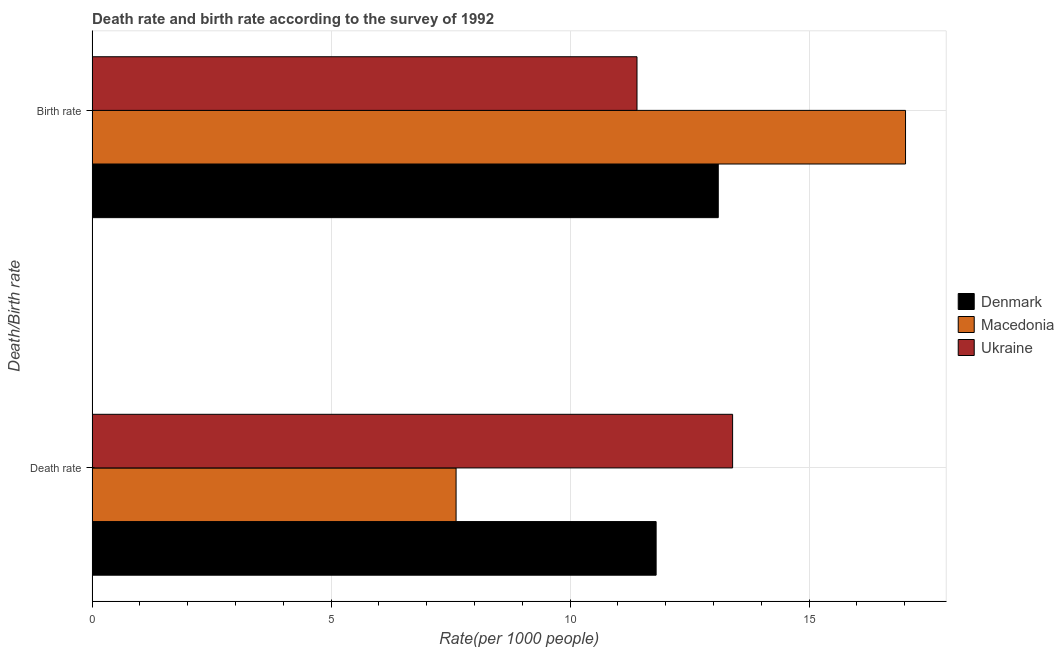How many bars are there on the 1st tick from the bottom?
Make the answer very short. 3. What is the label of the 1st group of bars from the top?
Keep it short and to the point. Birth rate. Across all countries, what is the maximum death rate?
Your response must be concise. 13.4. Across all countries, what is the minimum death rate?
Keep it short and to the point. 7.62. In which country was the birth rate maximum?
Your answer should be very brief. Macedonia. In which country was the death rate minimum?
Offer a terse response. Macedonia. What is the total birth rate in the graph?
Provide a short and direct response. 41.52. What is the difference between the death rate in Ukraine and that in Denmark?
Provide a short and direct response. 1.6. What is the difference between the death rate in Macedonia and the birth rate in Ukraine?
Your response must be concise. -3.79. What is the average birth rate per country?
Ensure brevity in your answer.  13.84. What is the difference between the death rate and birth rate in Denmark?
Your answer should be very brief. -1.3. What is the ratio of the death rate in Ukraine to that in Denmark?
Your response must be concise. 1.14. What does the 3rd bar from the bottom in Death rate represents?
Offer a very short reply. Ukraine. How many countries are there in the graph?
Your response must be concise. 3. Does the graph contain any zero values?
Your response must be concise. No. Where does the legend appear in the graph?
Your response must be concise. Center right. What is the title of the graph?
Offer a terse response. Death rate and birth rate according to the survey of 1992. Does "Bangladesh" appear as one of the legend labels in the graph?
Offer a very short reply. No. What is the label or title of the X-axis?
Provide a short and direct response. Rate(per 1000 people). What is the label or title of the Y-axis?
Make the answer very short. Death/Birth rate. What is the Rate(per 1000 people) in Denmark in Death rate?
Your answer should be compact. 11.8. What is the Rate(per 1000 people) of Macedonia in Death rate?
Your answer should be compact. 7.62. What is the Rate(per 1000 people) of Ukraine in Death rate?
Offer a terse response. 13.4. What is the Rate(per 1000 people) in Denmark in Birth rate?
Make the answer very short. 13.1. What is the Rate(per 1000 people) in Macedonia in Birth rate?
Your response must be concise. 17.02. Across all Death/Birth rate, what is the maximum Rate(per 1000 people) in Macedonia?
Give a very brief answer. 17.02. Across all Death/Birth rate, what is the minimum Rate(per 1000 people) in Denmark?
Keep it short and to the point. 11.8. Across all Death/Birth rate, what is the minimum Rate(per 1000 people) in Macedonia?
Offer a very short reply. 7.62. What is the total Rate(per 1000 people) of Denmark in the graph?
Give a very brief answer. 24.9. What is the total Rate(per 1000 people) in Macedonia in the graph?
Your answer should be compact. 24.63. What is the total Rate(per 1000 people) of Ukraine in the graph?
Offer a terse response. 24.8. What is the difference between the Rate(per 1000 people) in Denmark in Death rate and that in Birth rate?
Ensure brevity in your answer.  -1.3. What is the difference between the Rate(per 1000 people) of Macedonia in Death rate and that in Birth rate?
Your answer should be compact. -9.4. What is the difference between the Rate(per 1000 people) in Ukraine in Death rate and that in Birth rate?
Offer a very short reply. 2. What is the difference between the Rate(per 1000 people) of Denmark in Death rate and the Rate(per 1000 people) of Macedonia in Birth rate?
Offer a terse response. -5.22. What is the difference between the Rate(per 1000 people) of Denmark in Death rate and the Rate(per 1000 people) of Ukraine in Birth rate?
Provide a succinct answer. 0.4. What is the difference between the Rate(per 1000 people) of Macedonia in Death rate and the Rate(per 1000 people) of Ukraine in Birth rate?
Keep it short and to the point. -3.79. What is the average Rate(per 1000 people) in Denmark per Death/Birth rate?
Keep it short and to the point. 12.45. What is the average Rate(per 1000 people) of Macedonia per Death/Birth rate?
Ensure brevity in your answer.  12.32. What is the difference between the Rate(per 1000 people) in Denmark and Rate(per 1000 people) in Macedonia in Death rate?
Your answer should be compact. 4.18. What is the difference between the Rate(per 1000 people) in Denmark and Rate(per 1000 people) in Ukraine in Death rate?
Your answer should be very brief. -1.6. What is the difference between the Rate(per 1000 people) in Macedonia and Rate(per 1000 people) in Ukraine in Death rate?
Your response must be concise. -5.79. What is the difference between the Rate(per 1000 people) in Denmark and Rate(per 1000 people) in Macedonia in Birth rate?
Offer a very short reply. -3.92. What is the difference between the Rate(per 1000 people) in Macedonia and Rate(per 1000 people) in Ukraine in Birth rate?
Offer a terse response. 5.62. What is the ratio of the Rate(per 1000 people) of Denmark in Death rate to that in Birth rate?
Offer a terse response. 0.9. What is the ratio of the Rate(per 1000 people) of Macedonia in Death rate to that in Birth rate?
Your answer should be very brief. 0.45. What is the ratio of the Rate(per 1000 people) in Ukraine in Death rate to that in Birth rate?
Make the answer very short. 1.18. What is the difference between the highest and the second highest Rate(per 1000 people) of Macedonia?
Your response must be concise. 9.4. What is the difference between the highest and the second highest Rate(per 1000 people) in Ukraine?
Provide a succinct answer. 2. What is the difference between the highest and the lowest Rate(per 1000 people) in Denmark?
Your answer should be compact. 1.3. What is the difference between the highest and the lowest Rate(per 1000 people) of Macedonia?
Provide a short and direct response. 9.4. 